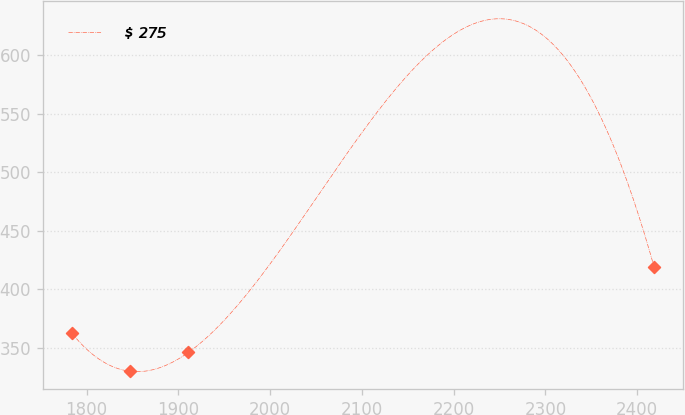Convert chart. <chart><loc_0><loc_0><loc_500><loc_500><line_chart><ecel><fcel>$ 275<nl><fcel>1783.97<fcel>362.51<nl><fcel>1847.43<fcel>329.92<nl><fcel>1910.89<fcel>345.96<nl><fcel>2418.53<fcel>418.65<nl></chart> 